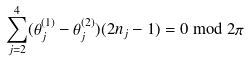Convert formula to latex. <formula><loc_0><loc_0><loc_500><loc_500>\sum _ { j = 2 } ^ { 4 } ( \theta _ { j } ^ { ( 1 ) } - \theta _ { j } ^ { ( 2 ) } ) ( 2 n _ { j } - 1 ) = 0 \bmod 2 \pi</formula> 